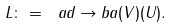Convert formula to latex. <formula><loc_0><loc_0><loc_500><loc_500>L \colon = \ a d \to b a ( V ) ( U ) .</formula> 